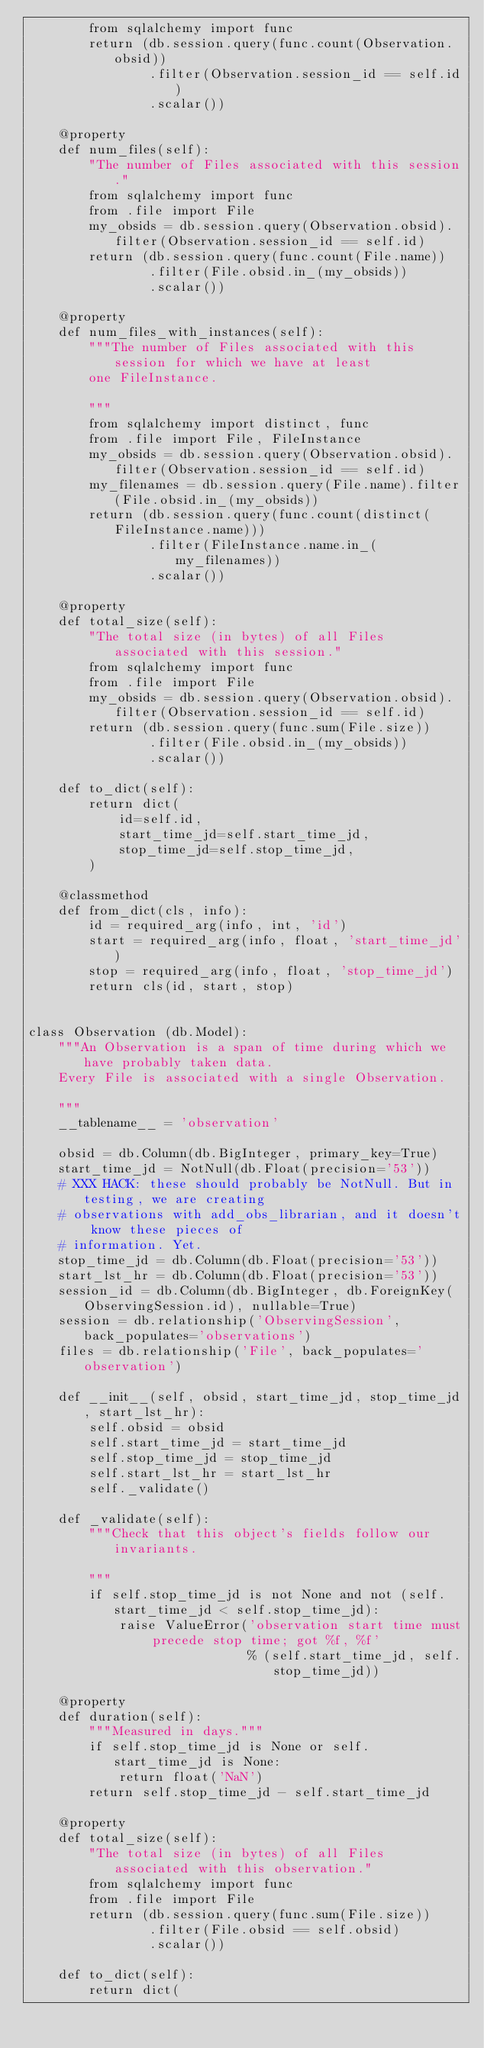Convert code to text. <code><loc_0><loc_0><loc_500><loc_500><_Python_>        from sqlalchemy import func
        return (db.session.query(func.count(Observation.obsid))
                .filter(Observation.session_id == self.id)
                .scalar())

    @property
    def num_files(self):
        "The number of Files associated with this session."
        from sqlalchemy import func
        from .file import File
        my_obsids = db.session.query(Observation.obsid).filter(Observation.session_id == self.id)
        return (db.session.query(func.count(File.name))
                .filter(File.obsid.in_(my_obsids))
                .scalar())

    @property
    def num_files_with_instances(self):
        """The number of Files associated with this session for which we have at least
        one FileInstance.

        """
        from sqlalchemy import distinct, func
        from .file import File, FileInstance
        my_obsids = db.session.query(Observation.obsid).filter(Observation.session_id == self.id)
        my_filenames = db.session.query(File.name).filter(File.obsid.in_(my_obsids))
        return (db.session.query(func.count(distinct(FileInstance.name)))
                .filter(FileInstance.name.in_(my_filenames))
                .scalar())

    @property
    def total_size(self):
        "The total size (in bytes) of all Files associated with this session."
        from sqlalchemy import func
        from .file import File
        my_obsids = db.session.query(Observation.obsid).filter(Observation.session_id == self.id)
        return (db.session.query(func.sum(File.size))
                .filter(File.obsid.in_(my_obsids))
                .scalar())

    def to_dict(self):
        return dict(
            id=self.id,
            start_time_jd=self.start_time_jd,
            stop_time_jd=self.stop_time_jd,
        )

    @classmethod
    def from_dict(cls, info):
        id = required_arg(info, int, 'id')
        start = required_arg(info, float, 'start_time_jd')
        stop = required_arg(info, float, 'stop_time_jd')
        return cls(id, start, stop)


class Observation (db.Model):
    """An Observation is a span of time during which we have probably taken data.
    Every File is associated with a single Observation.

    """
    __tablename__ = 'observation'

    obsid = db.Column(db.BigInteger, primary_key=True)
    start_time_jd = NotNull(db.Float(precision='53'))
    # XXX HACK: these should probably be NotNull. But in testing, we are creating
    # observations with add_obs_librarian, and it doesn't know these pieces of
    # information. Yet.
    stop_time_jd = db.Column(db.Float(precision='53'))
    start_lst_hr = db.Column(db.Float(precision='53'))
    session_id = db.Column(db.BigInteger, db.ForeignKey(ObservingSession.id), nullable=True)
    session = db.relationship('ObservingSession', back_populates='observations')
    files = db.relationship('File', back_populates='observation')

    def __init__(self, obsid, start_time_jd, stop_time_jd, start_lst_hr):
        self.obsid = obsid
        self.start_time_jd = start_time_jd
        self.stop_time_jd = stop_time_jd
        self.start_lst_hr = start_lst_hr
        self._validate()

    def _validate(self):
        """Check that this object's fields follow our invariants.

        """
        if self.stop_time_jd is not None and not (self.start_time_jd < self.stop_time_jd):
            raise ValueError('observation start time must precede stop time; got %f, %f'
                             % (self.start_time_jd, self.stop_time_jd))

    @property
    def duration(self):
        """Measured in days."""
        if self.stop_time_jd is None or self.start_time_jd is None:
            return float('NaN')
        return self.stop_time_jd - self.start_time_jd

    @property
    def total_size(self):
        "The total size (in bytes) of all Files associated with this observation."
        from sqlalchemy import func
        from .file import File
        return (db.session.query(func.sum(File.size))
                .filter(File.obsid == self.obsid)
                .scalar())

    def to_dict(self):
        return dict(</code> 